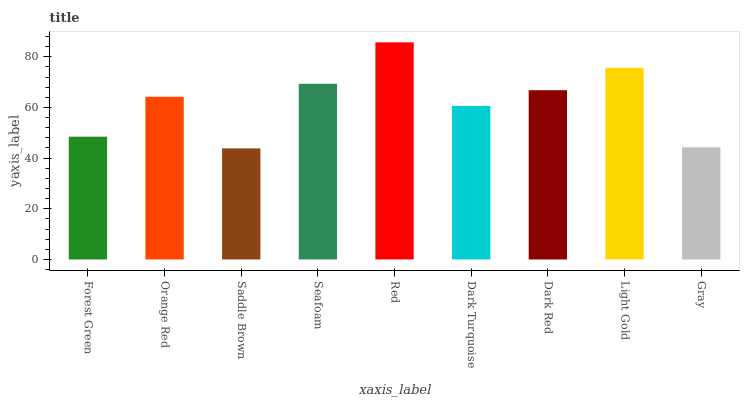Is Saddle Brown the minimum?
Answer yes or no. Yes. Is Red the maximum?
Answer yes or no. Yes. Is Orange Red the minimum?
Answer yes or no. No. Is Orange Red the maximum?
Answer yes or no. No. Is Orange Red greater than Forest Green?
Answer yes or no. Yes. Is Forest Green less than Orange Red?
Answer yes or no. Yes. Is Forest Green greater than Orange Red?
Answer yes or no. No. Is Orange Red less than Forest Green?
Answer yes or no. No. Is Orange Red the high median?
Answer yes or no. Yes. Is Orange Red the low median?
Answer yes or no. Yes. Is Dark Red the high median?
Answer yes or no. No. Is Dark Turquoise the low median?
Answer yes or no. No. 